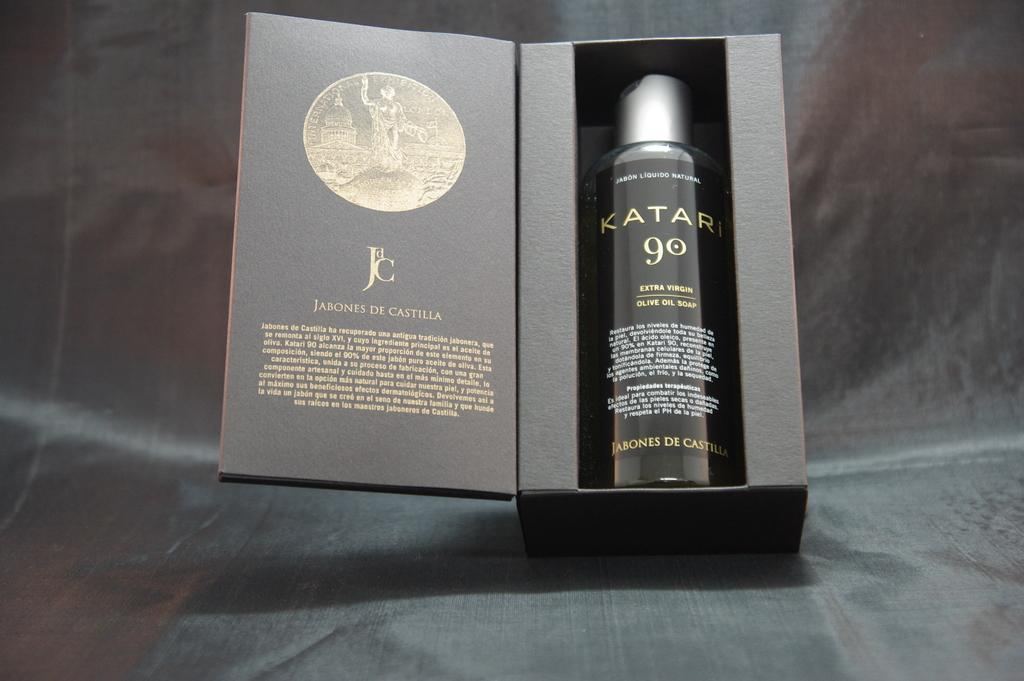<image>
Create a compact narrative representing the image presented. A bottle of Katari 90 sits brand new in a black box. 